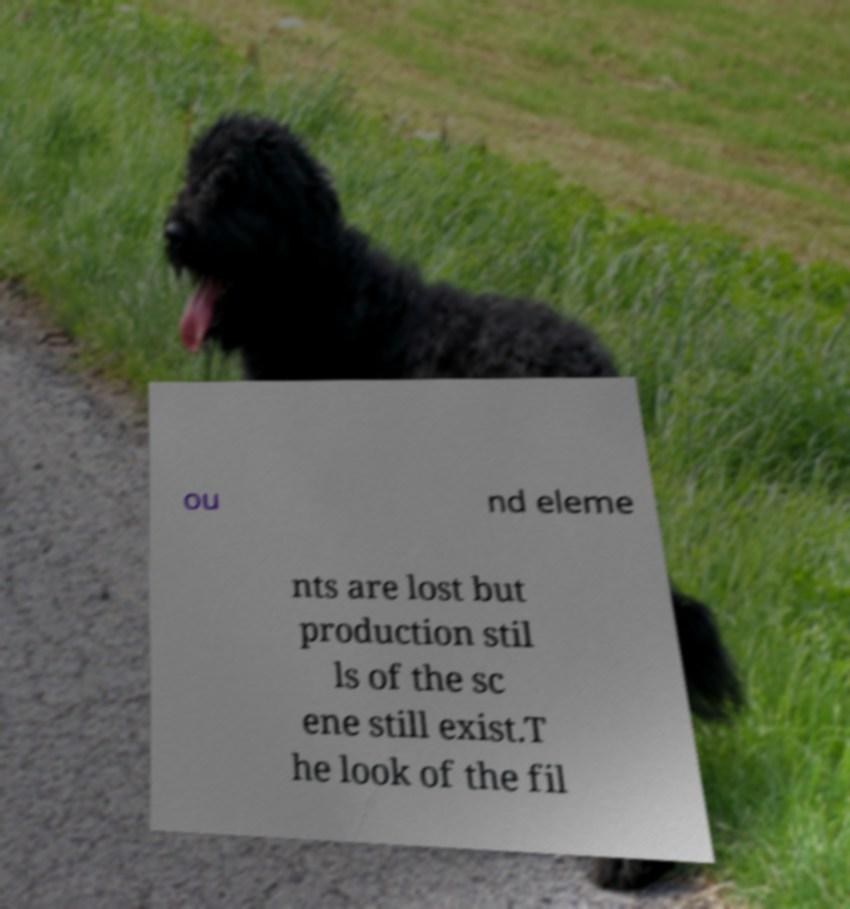I need the written content from this picture converted into text. Can you do that? ou nd eleme nts are lost but production stil ls of the sc ene still exist.T he look of the fil 